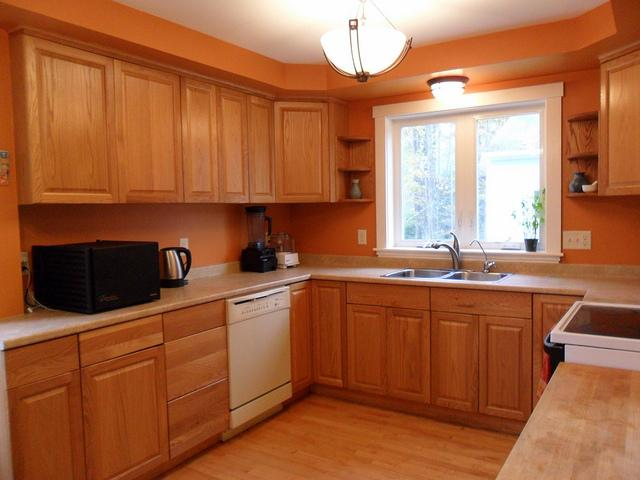What is the black appliance by the corner called?

Choices:
A) food processor
B) can opener
C) blender
D) microwave blender 